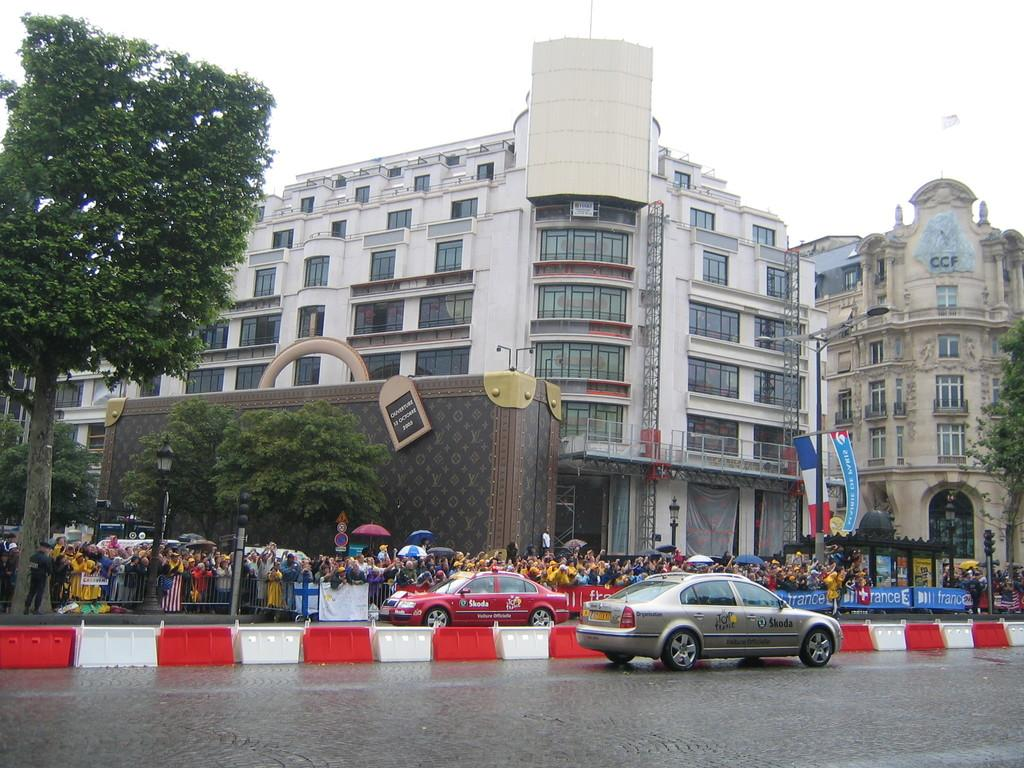<image>
Summarize the visual content of the image. A silver car in a street with the word Skoda on it. 